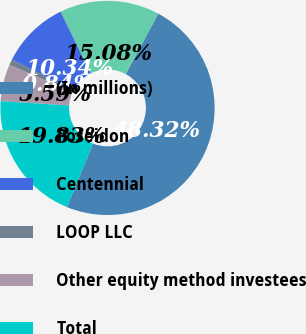Convert chart. <chart><loc_0><loc_0><loc_500><loc_500><pie_chart><fcel>(In millions)<fcel>Poseidon<fcel>Centennial<fcel>LOOP LLC<fcel>Other equity method investees<fcel>Total<nl><fcel>48.32%<fcel>15.08%<fcel>10.34%<fcel>0.84%<fcel>5.59%<fcel>19.83%<nl></chart> 